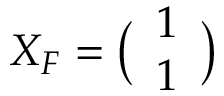<formula> <loc_0><loc_0><loc_500><loc_500>X _ { F } = \left ( \begin{array} { l } { 1 } \\ { 1 } \end{array} \right )</formula> 